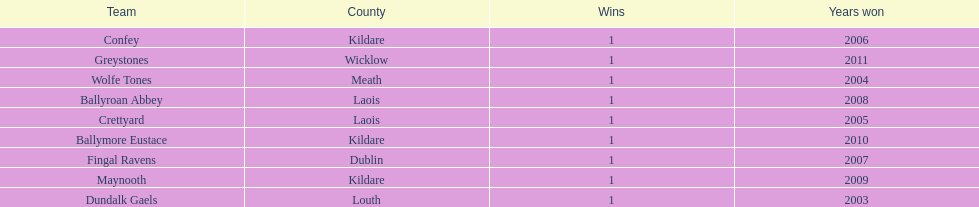What is the difference years won for crettyard and greystones 6. 